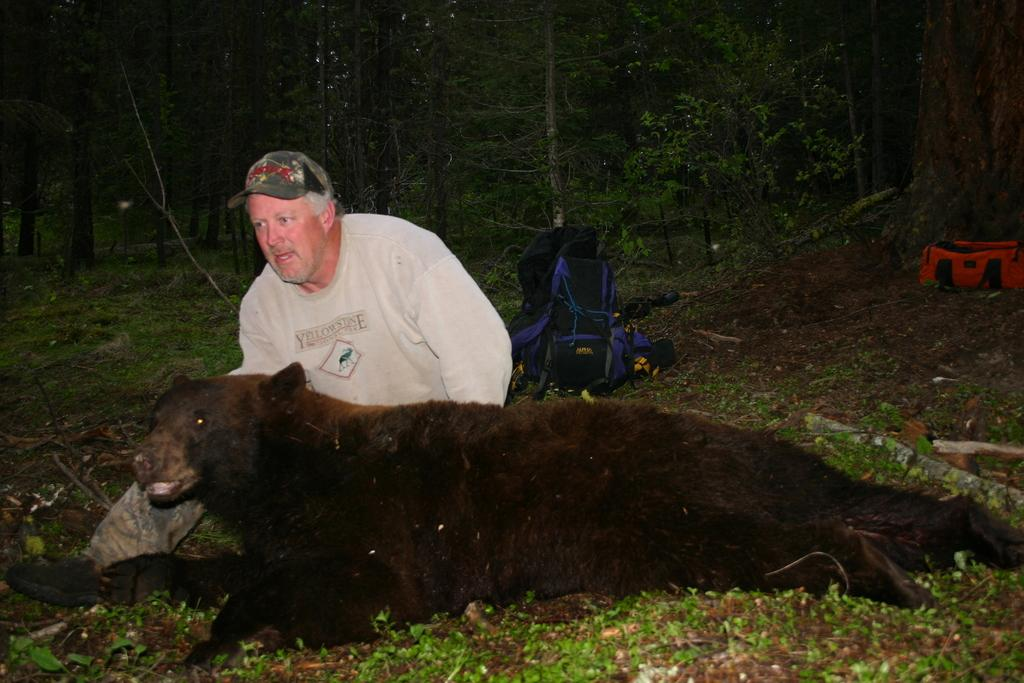What animal can be seen in the image? There is a bear in the image. Can you describe the person in the image? There is a person wearing a cap in the image. What objects are visible in the background of the image? There are bags and trees in the background of the image. What type of feather can be seen on the bear's head in the image? There is no feather present on the bear's head in the image. Is there a table visible in the image? There is no table present in the image. 